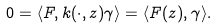Convert formula to latex. <formula><loc_0><loc_0><loc_500><loc_500>0 = \langle F , k ( \cdot , z ) \gamma \rangle = \langle F ( z ) , \gamma \rangle .</formula> 